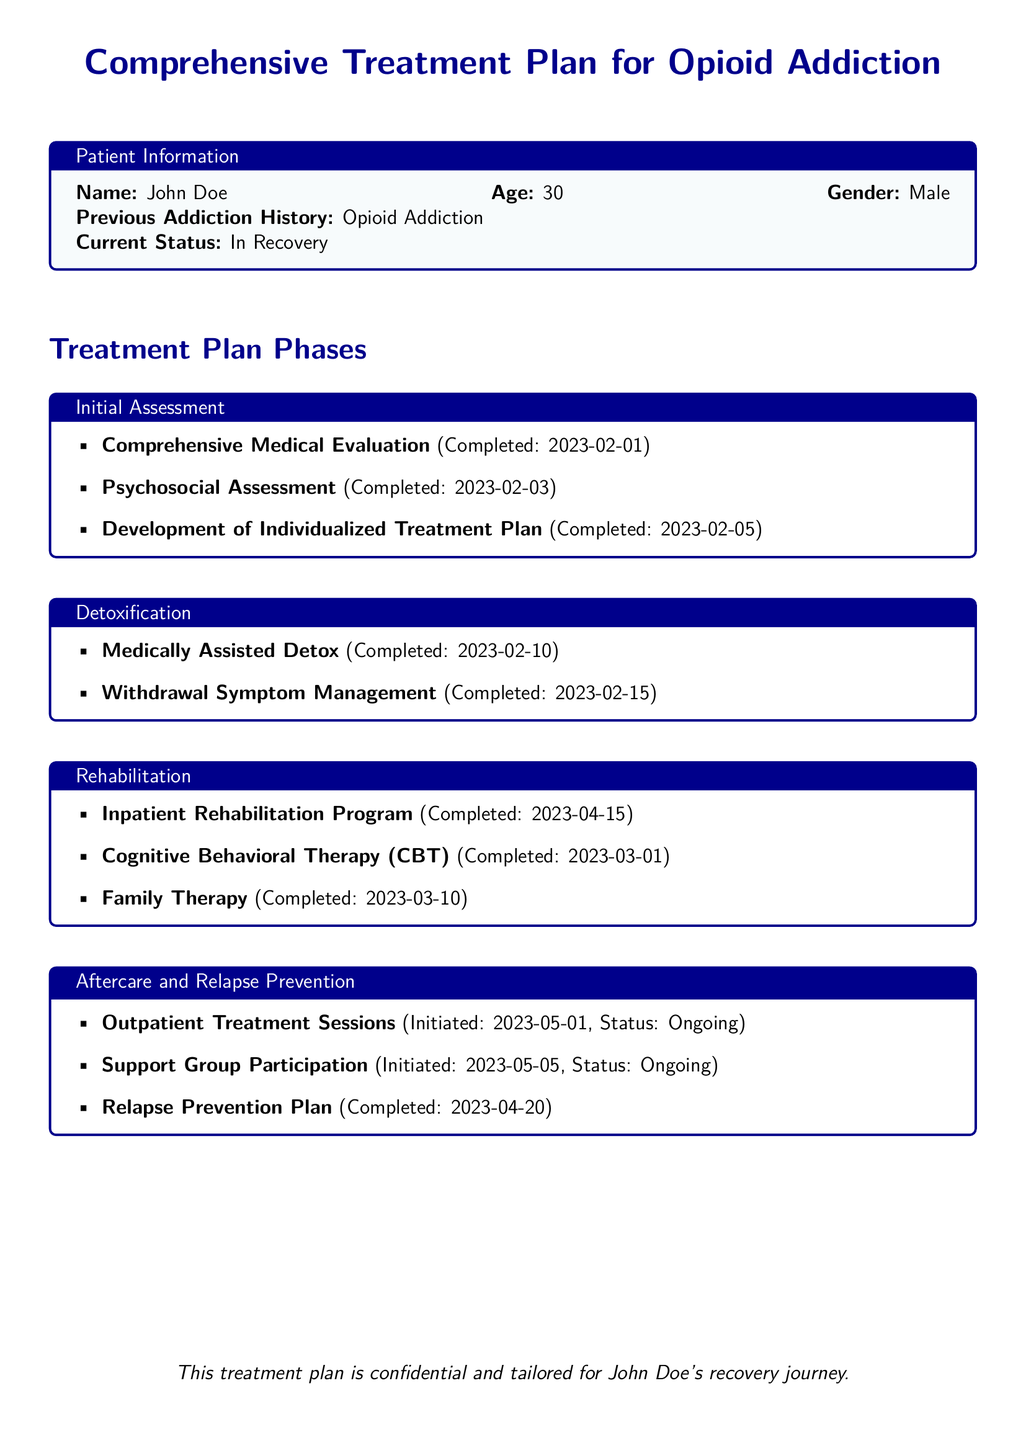What is the name of the patient? The patient's name is indicated in the patient information section of the document.
Answer: John Doe What is the age of the patient? The age of the patient is listed in the patient information section.
Answer: 30 What is the completed date for the psychosocial assessment? The document specifies the completed date for the psychosocial assessment under the Initial Assessment phase.
Answer: 2023-02-03 What therapy was completed on March 10, 2023? The document includes a list of therapies and their completion dates, including family therapy.
Answer: Family Therapy When were the outpatient treatment sessions initiated? The start date for outpatient treatment sessions is noted under the Aftercare and Relapse Prevention section.
Answer: 2023-05-01 How many phases are outlined in the treatment plan? The document categorizes the treatment into distinct phases, which can be counted.
Answer: Four phases What type of therapy was used in the rehabilitation phase? The document specifies the types of therapy included in the rehabilitation phase, highlighting cognitive behavioral therapy.
Answer: Cognitive Behavioral Therapy (CBT) What is the status of the support group participation? The status of the support group is mentioned in the Aftercare and Relapse Prevention section.
Answer: Ongoing What did the relapse prevention plan complete? Details about the completion of the relapse prevention plan are provided in the Aftercare and Relapse Prevention phase.
Answer: 2023-04-20 